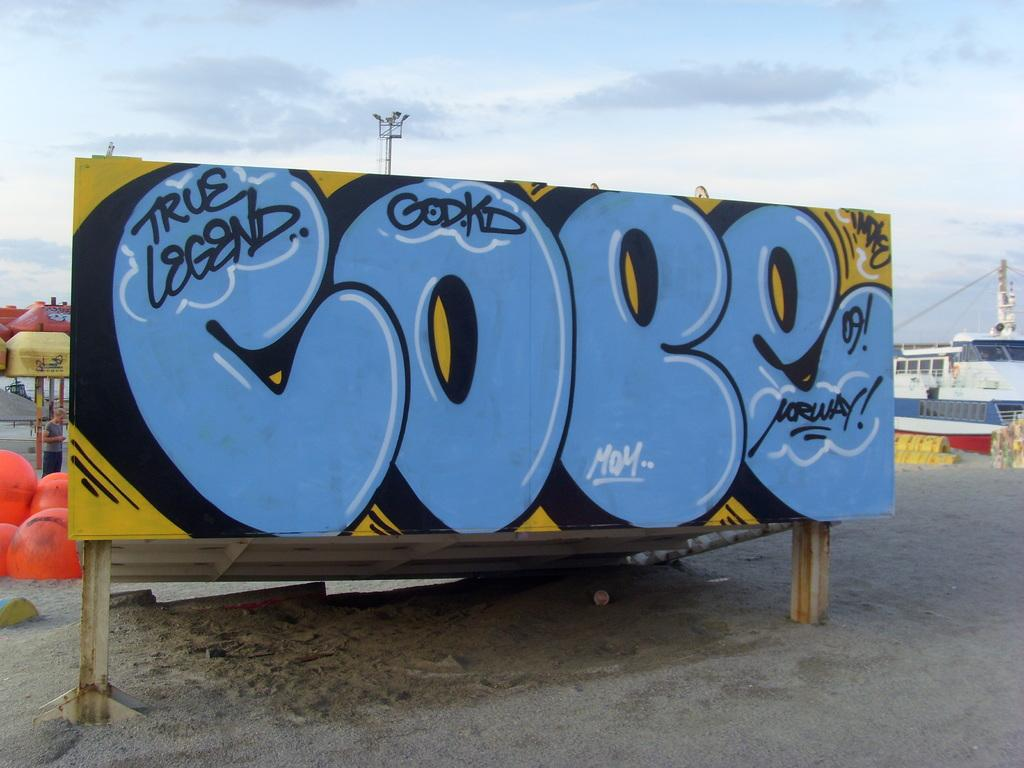<image>
Provide a brief description of the given image. True Legend is spray painted on a wall. 